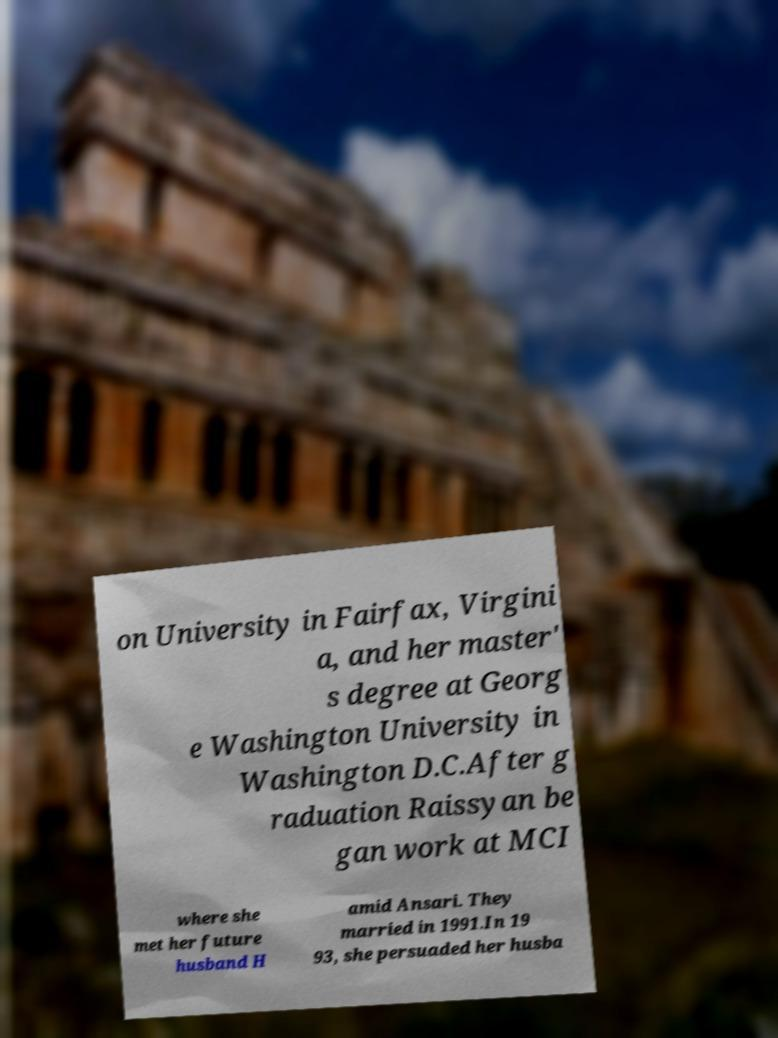Can you read and provide the text displayed in the image?This photo seems to have some interesting text. Can you extract and type it out for me? on University in Fairfax, Virgini a, and her master' s degree at Georg e Washington University in Washington D.C.After g raduation Raissyan be gan work at MCI where she met her future husband H amid Ansari. They married in 1991.In 19 93, she persuaded her husba 